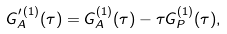<formula> <loc_0><loc_0><loc_500><loc_500>G _ { A } ^ { \prime \, ( 1 ) } ( \tau ) = G _ { A } ^ { ( 1 ) } ( \tau ) - \tau G _ { P } ^ { ( 1 ) } ( \tau ) ,</formula> 